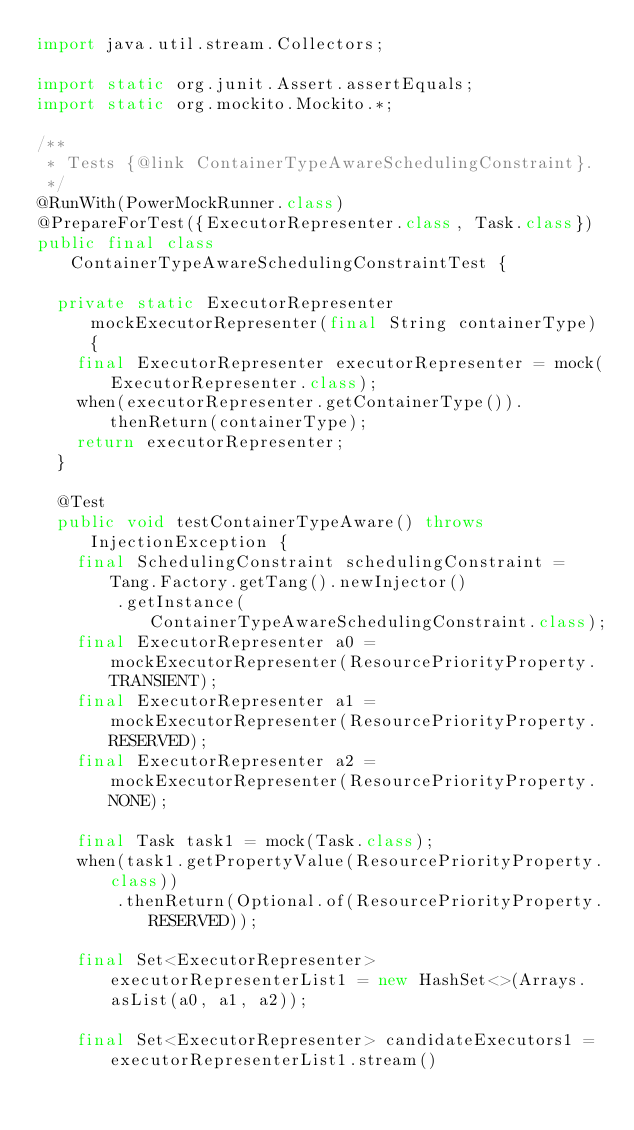<code> <loc_0><loc_0><loc_500><loc_500><_Java_>import java.util.stream.Collectors;

import static org.junit.Assert.assertEquals;
import static org.mockito.Mockito.*;

/**
 * Tests {@link ContainerTypeAwareSchedulingConstraint}.
 */
@RunWith(PowerMockRunner.class)
@PrepareForTest({ExecutorRepresenter.class, Task.class})
public final class ContainerTypeAwareSchedulingConstraintTest {

  private static ExecutorRepresenter mockExecutorRepresenter(final String containerType) {
    final ExecutorRepresenter executorRepresenter = mock(ExecutorRepresenter.class);
    when(executorRepresenter.getContainerType()).thenReturn(containerType);
    return executorRepresenter;
  }

  @Test
  public void testContainerTypeAware() throws InjectionException {
    final SchedulingConstraint schedulingConstraint = Tang.Factory.getTang().newInjector()
        .getInstance(ContainerTypeAwareSchedulingConstraint.class);
    final ExecutorRepresenter a0 = mockExecutorRepresenter(ResourcePriorityProperty.TRANSIENT);
    final ExecutorRepresenter a1 = mockExecutorRepresenter(ResourcePriorityProperty.RESERVED);
    final ExecutorRepresenter a2 = mockExecutorRepresenter(ResourcePriorityProperty.NONE);

    final Task task1 = mock(Task.class);
    when(task1.getPropertyValue(ResourcePriorityProperty.class))
        .thenReturn(Optional.of(ResourcePriorityProperty.RESERVED));

    final Set<ExecutorRepresenter> executorRepresenterList1 = new HashSet<>(Arrays.asList(a0, a1, a2));

    final Set<ExecutorRepresenter> candidateExecutors1 = executorRepresenterList1.stream()</code> 